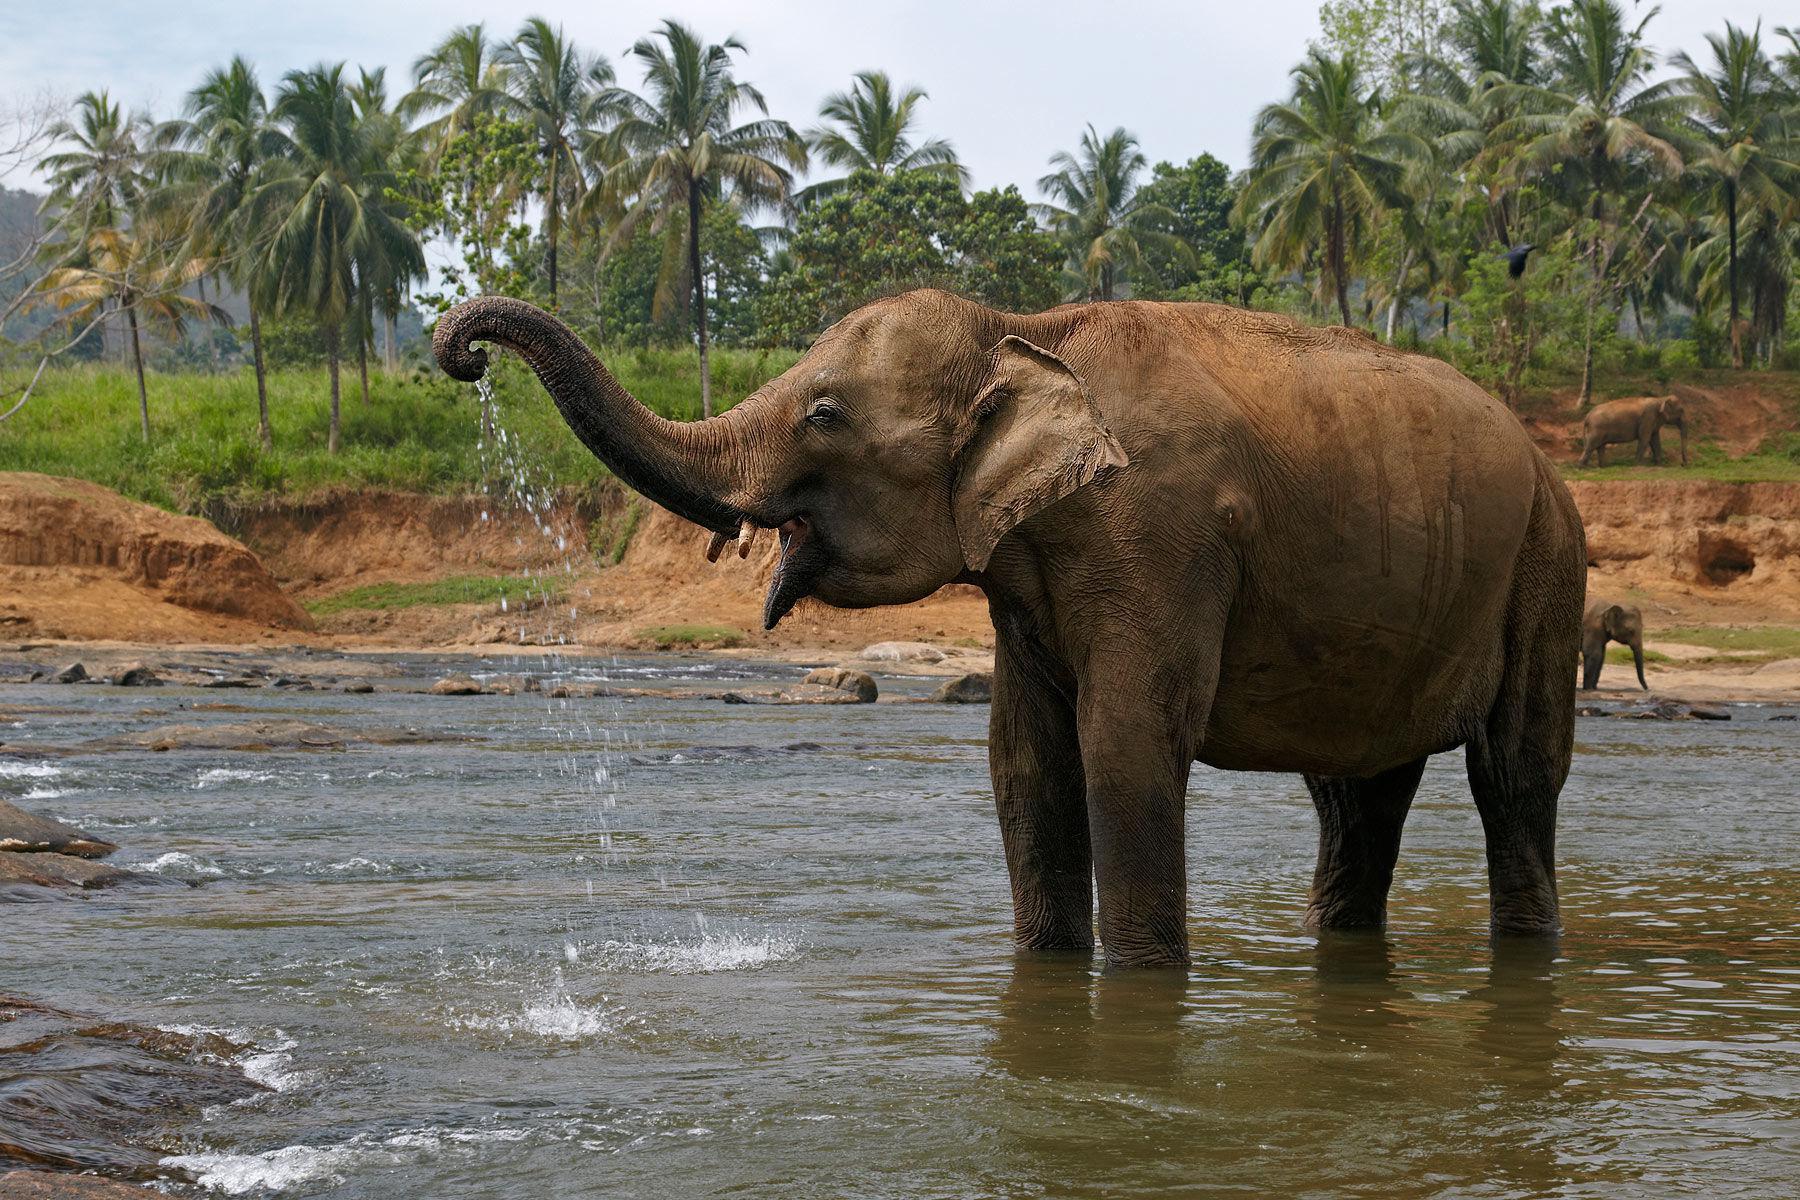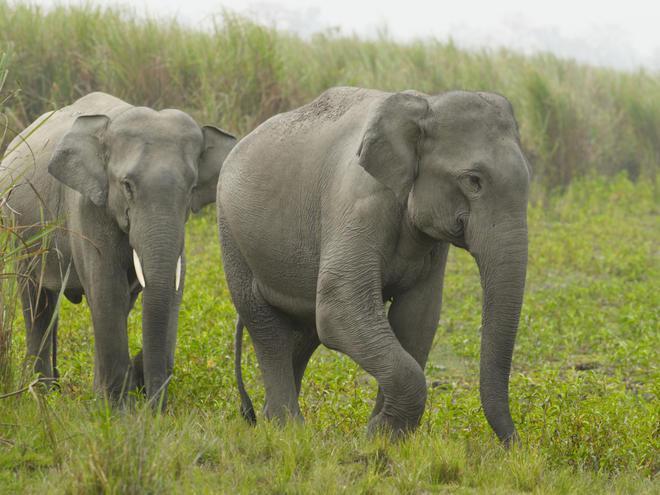The first image is the image on the left, the second image is the image on the right. Analyze the images presented: Is the assertion "An image shows one or more adult elephants with trunk raised at least head-high." valid? Answer yes or no. Yes. 